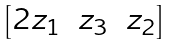Convert formula to latex. <formula><loc_0><loc_0><loc_500><loc_500>\begin{bmatrix} 2 z _ { 1 } & z _ { 3 } & z _ { 2 } \end{bmatrix}</formula> 